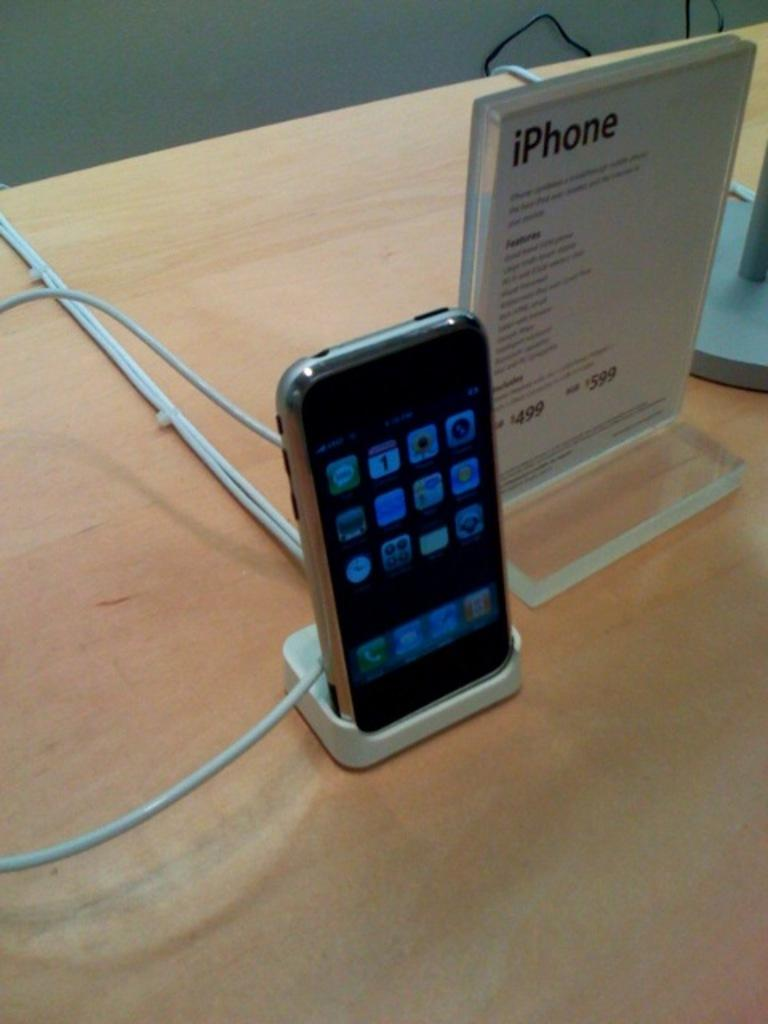<image>
Summarize the visual content of the image. an iPhone on display next to a sign for it 